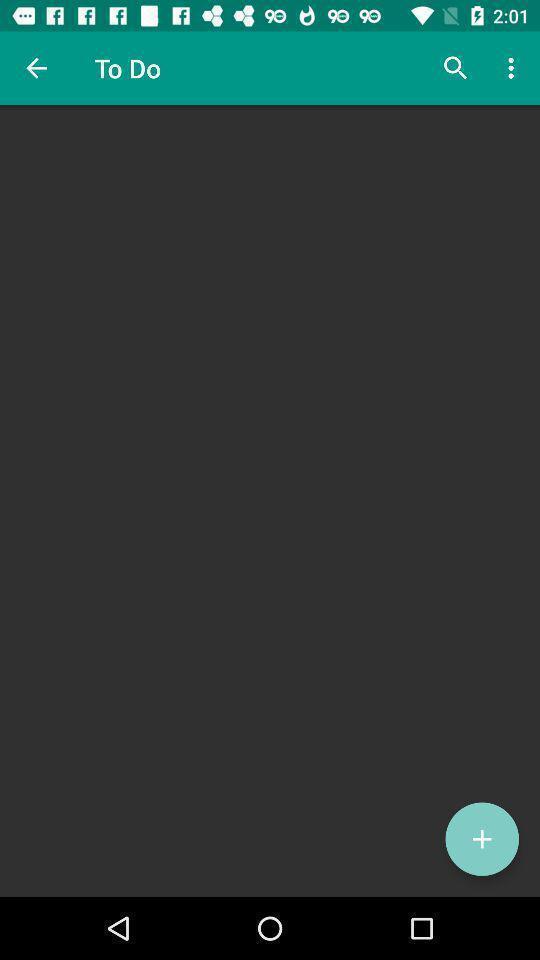Please provide a description for this image. To do list and to add the option. 